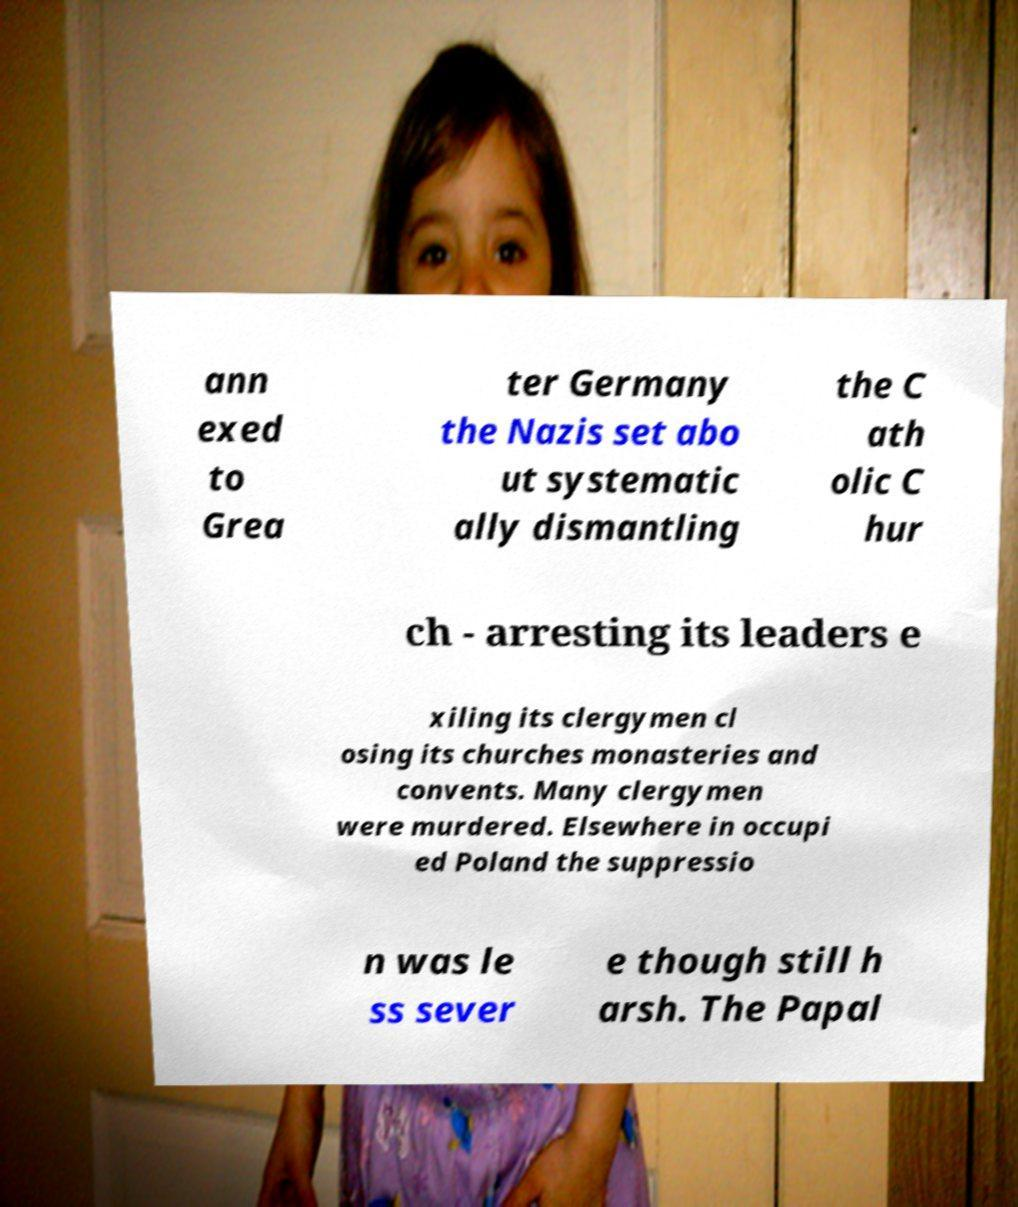Can you read and provide the text displayed in the image?This photo seems to have some interesting text. Can you extract and type it out for me? ann exed to Grea ter Germany the Nazis set abo ut systematic ally dismantling the C ath olic C hur ch - arresting its leaders e xiling its clergymen cl osing its churches monasteries and convents. Many clergymen were murdered. Elsewhere in occupi ed Poland the suppressio n was le ss sever e though still h arsh. The Papal 